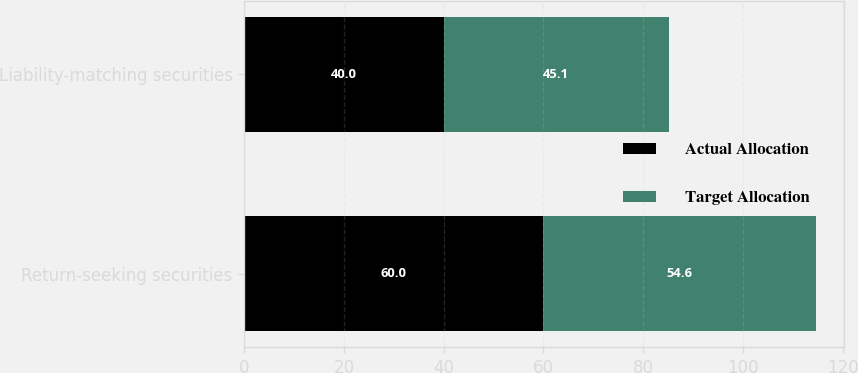Convert chart. <chart><loc_0><loc_0><loc_500><loc_500><stacked_bar_chart><ecel><fcel>Return-seeking securities<fcel>Liability-matching securities<nl><fcel>Actual Allocation<fcel>60<fcel>40<nl><fcel>Target Allocation<fcel>54.6<fcel>45.1<nl></chart> 